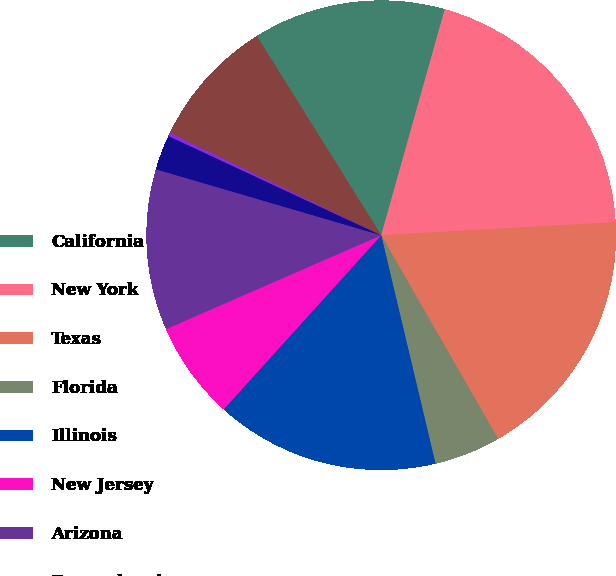<chart> <loc_0><loc_0><loc_500><loc_500><pie_chart><fcel>California<fcel>New York<fcel>Texas<fcel>Florida<fcel>Illinois<fcel>New Jersey<fcel>Arizona<fcel>Pennsylvania<fcel>Washington<fcel>Colorado<nl><fcel>13.25%<fcel>19.75%<fcel>17.59%<fcel>4.58%<fcel>15.42%<fcel>6.75%<fcel>11.08%<fcel>2.41%<fcel>0.25%<fcel>8.92%<nl></chart> 